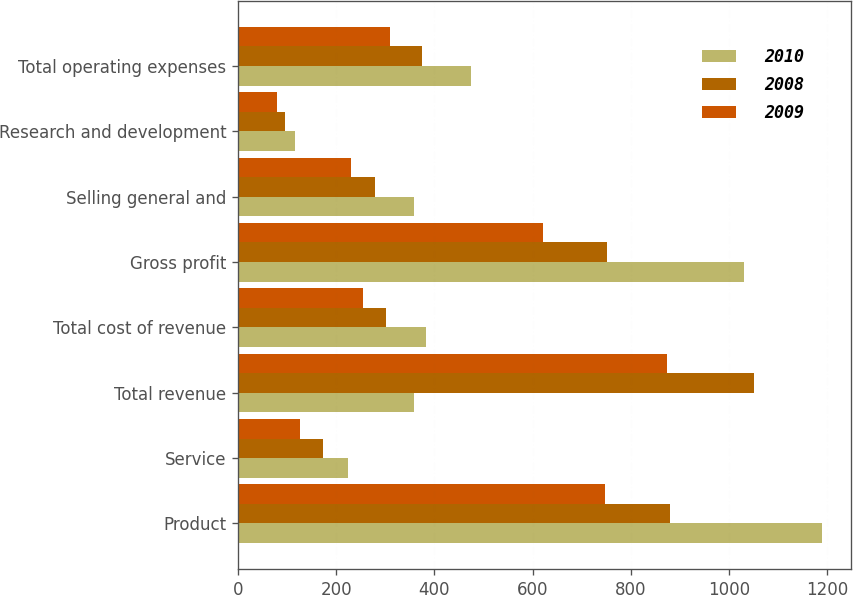<chart> <loc_0><loc_0><loc_500><loc_500><stacked_bar_chart><ecel><fcel>Product<fcel>Service<fcel>Total revenue<fcel>Total cost of revenue<fcel>Gross profit<fcel>Selling general and<fcel>Research and development<fcel>Total operating expenses<nl><fcel>2010<fcel>1189.1<fcel>223.9<fcel>358.8<fcel>383<fcel>1030<fcel>358.8<fcel>116<fcel>474.8<nl><fcel>2008<fcel>879.9<fcel>172.3<fcel>1052.2<fcel>301.1<fcel>751.1<fcel>278.6<fcel>95.1<fcel>373.7<nl><fcel>2009<fcel>748.3<fcel>126.6<fcel>874.9<fcel>254.1<fcel>620.8<fcel>230.6<fcel>79.4<fcel>310<nl></chart> 